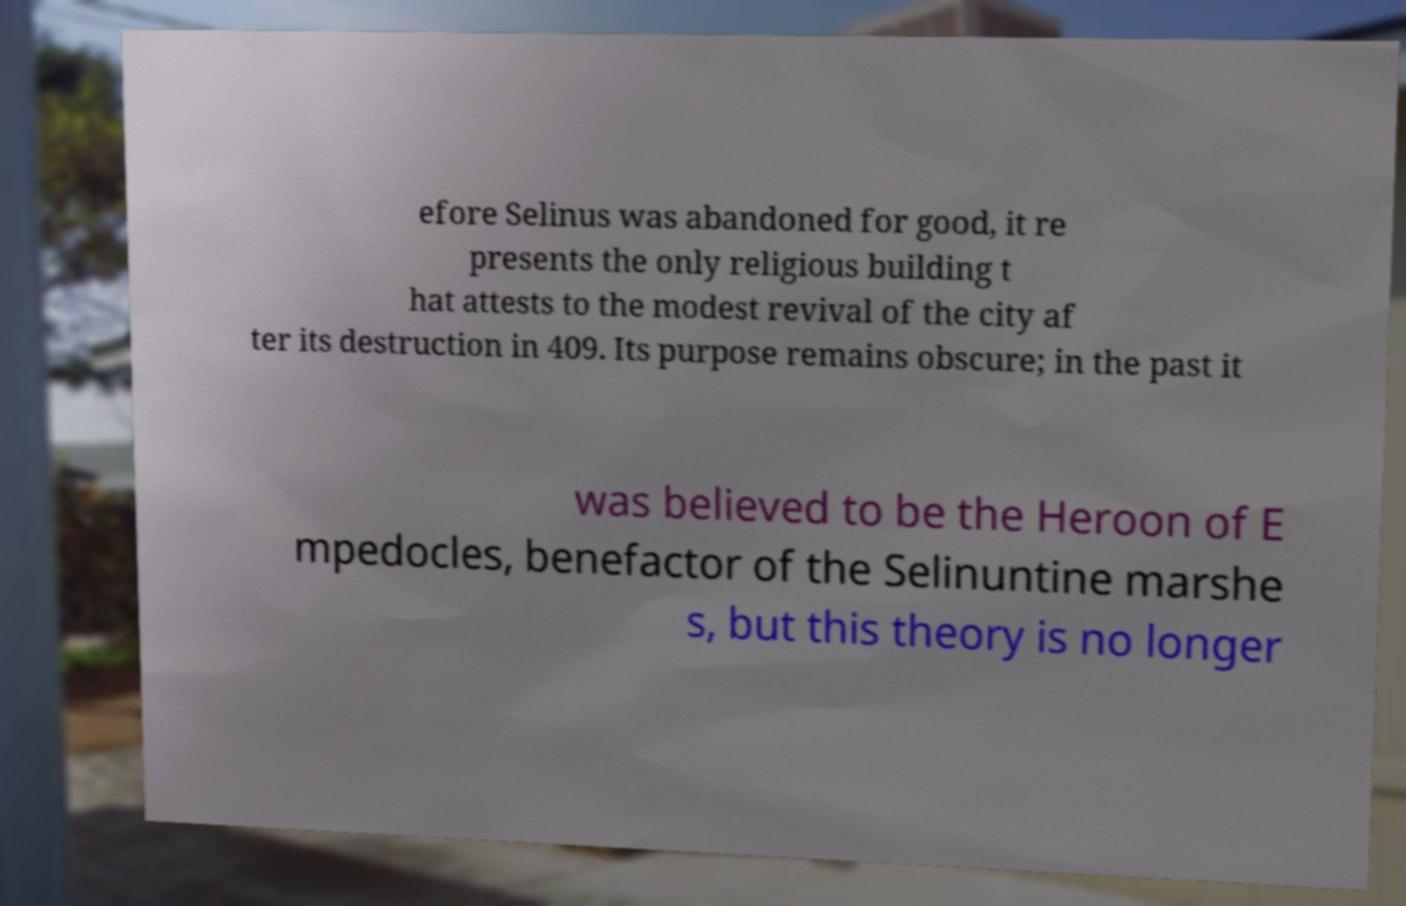Can you accurately transcribe the text from the provided image for me? efore Selinus was abandoned for good, it re presents the only religious building t hat attests to the modest revival of the city af ter its destruction in 409. Its purpose remains obscure; in the past it was believed to be the Heroon of E mpedocles, benefactor of the Selinuntine marshe s, but this theory is no longer 